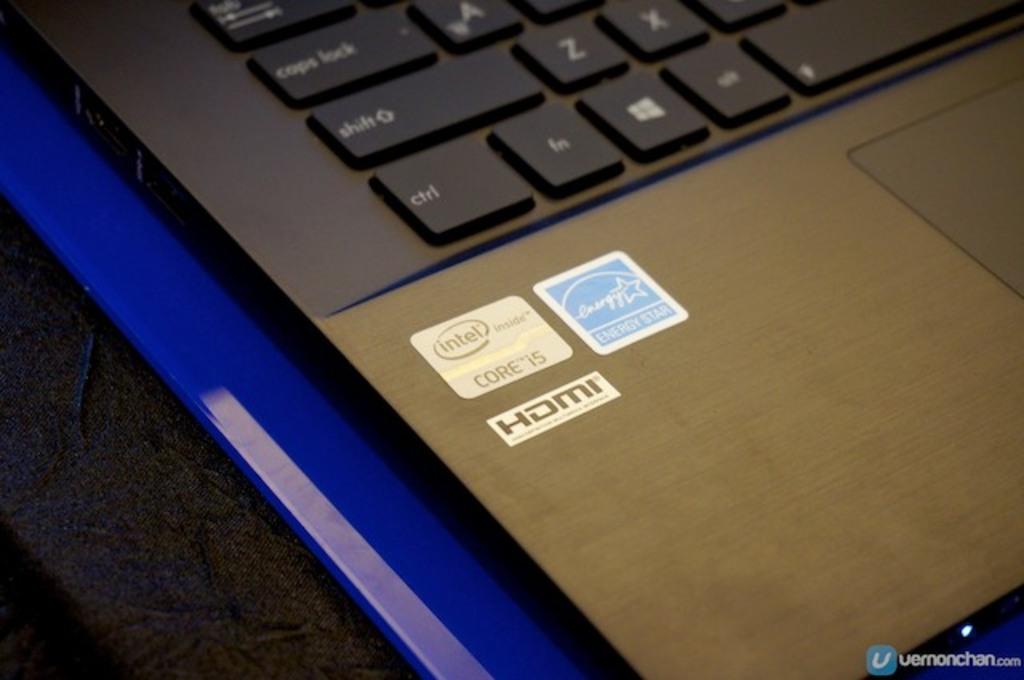What type of processor is this?
Provide a succinct answer. Intel. Does this have hdmi?
Ensure brevity in your answer.  Yes. 